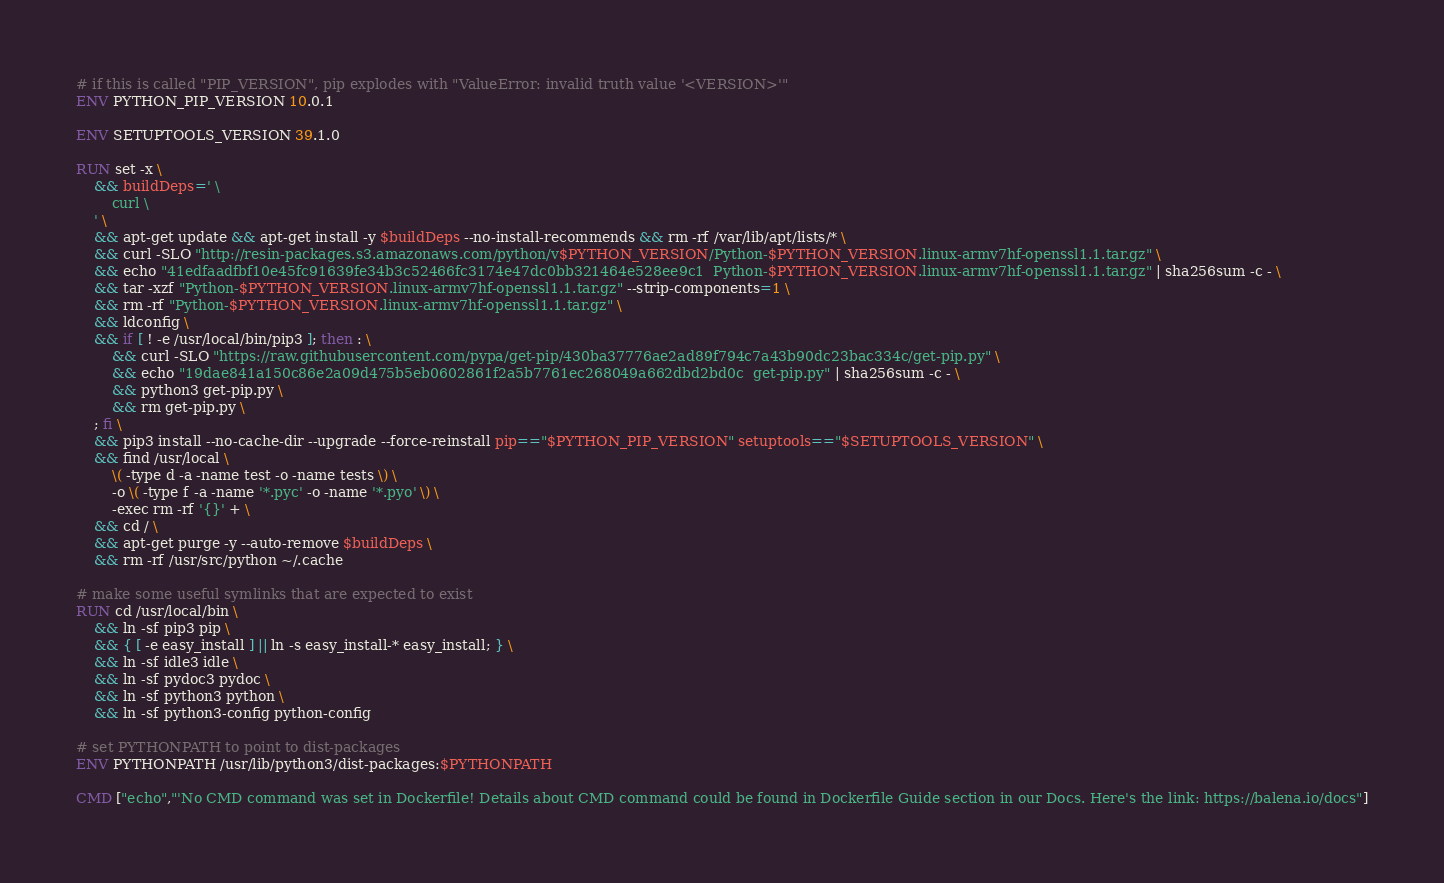Convert code to text. <code><loc_0><loc_0><loc_500><loc_500><_Dockerfile_># if this is called "PIP_VERSION", pip explodes with "ValueError: invalid truth value '<VERSION>'"
ENV PYTHON_PIP_VERSION 10.0.1

ENV SETUPTOOLS_VERSION 39.1.0

RUN set -x \
	&& buildDeps=' \
		curl \
	' \
	&& apt-get update && apt-get install -y $buildDeps --no-install-recommends && rm -rf /var/lib/apt/lists/* \
	&& curl -SLO "http://resin-packages.s3.amazonaws.com/python/v$PYTHON_VERSION/Python-$PYTHON_VERSION.linux-armv7hf-openssl1.1.tar.gz" \
	&& echo "41edfaadfbf10e45fc91639fe34b3c52466fc3174e47dc0bb321464e528ee9c1  Python-$PYTHON_VERSION.linux-armv7hf-openssl1.1.tar.gz" | sha256sum -c - \
	&& tar -xzf "Python-$PYTHON_VERSION.linux-armv7hf-openssl1.1.tar.gz" --strip-components=1 \
	&& rm -rf "Python-$PYTHON_VERSION.linux-armv7hf-openssl1.1.tar.gz" \
	&& ldconfig \
	&& if [ ! -e /usr/local/bin/pip3 ]; then : \
		&& curl -SLO "https://raw.githubusercontent.com/pypa/get-pip/430ba37776ae2ad89f794c7a43b90dc23bac334c/get-pip.py" \
		&& echo "19dae841a150c86e2a09d475b5eb0602861f2a5b7761ec268049a662dbd2bd0c  get-pip.py" | sha256sum -c - \
		&& python3 get-pip.py \
		&& rm get-pip.py \
	; fi \
	&& pip3 install --no-cache-dir --upgrade --force-reinstall pip=="$PYTHON_PIP_VERSION" setuptools=="$SETUPTOOLS_VERSION" \
	&& find /usr/local \
		\( -type d -a -name test -o -name tests \) \
		-o \( -type f -a -name '*.pyc' -o -name '*.pyo' \) \
		-exec rm -rf '{}' + \
	&& cd / \
	&& apt-get purge -y --auto-remove $buildDeps \
	&& rm -rf /usr/src/python ~/.cache

# make some useful symlinks that are expected to exist
RUN cd /usr/local/bin \
	&& ln -sf pip3 pip \
	&& { [ -e easy_install ] || ln -s easy_install-* easy_install; } \
	&& ln -sf idle3 idle \
	&& ln -sf pydoc3 pydoc \
	&& ln -sf python3 python \
	&& ln -sf python3-config python-config

# set PYTHONPATH to point to dist-packages
ENV PYTHONPATH /usr/lib/python3/dist-packages:$PYTHONPATH

CMD ["echo","'No CMD command was set in Dockerfile! Details about CMD command could be found in Dockerfile Guide section in our Docs. Here's the link: https://balena.io/docs"]</code> 